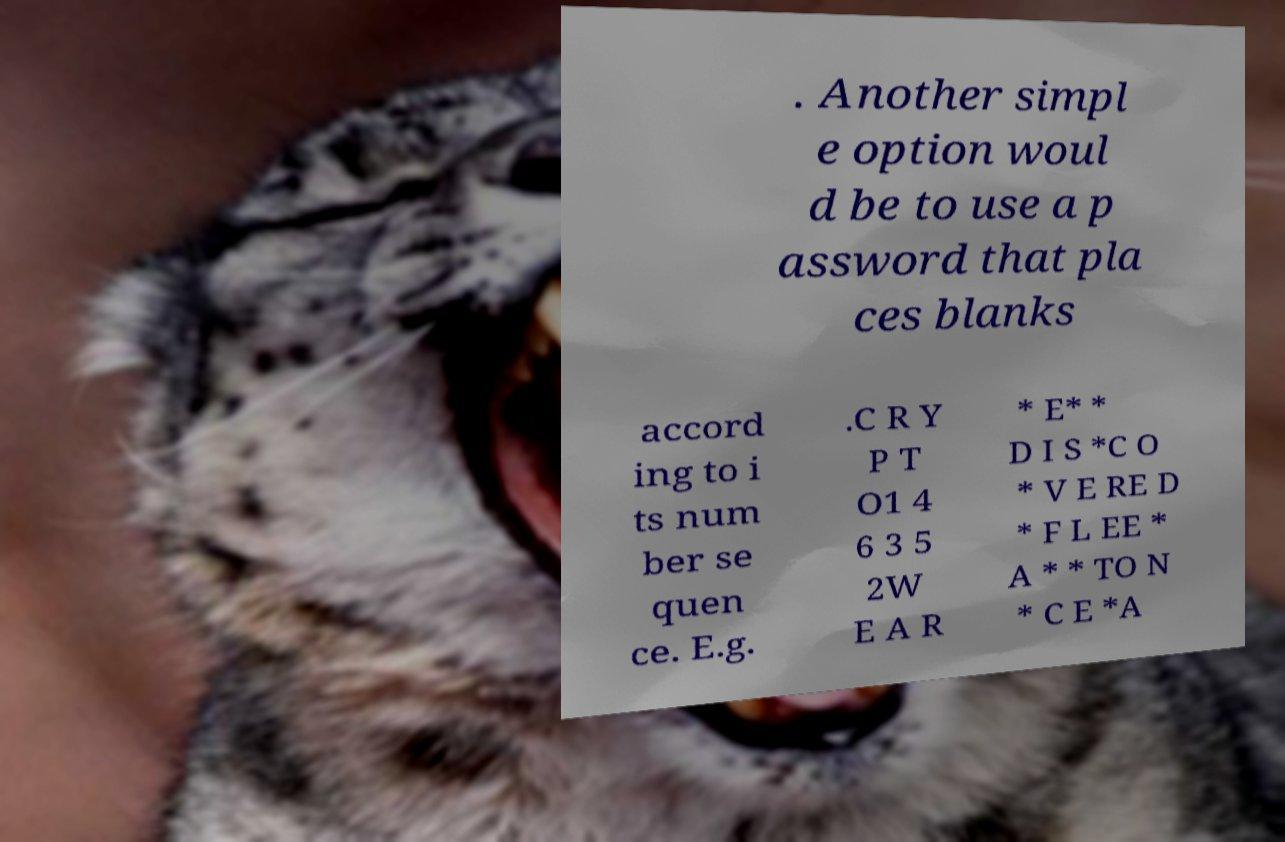Can you accurately transcribe the text from the provided image for me? . Another simpl e option woul d be to use a p assword that pla ces blanks accord ing to i ts num ber se quen ce. E.g. .C R Y P T O1 4 6 3 5 2W E A R * E* * D I S *C O * V E RE D * F L EE * A * * TO N * C E *A 